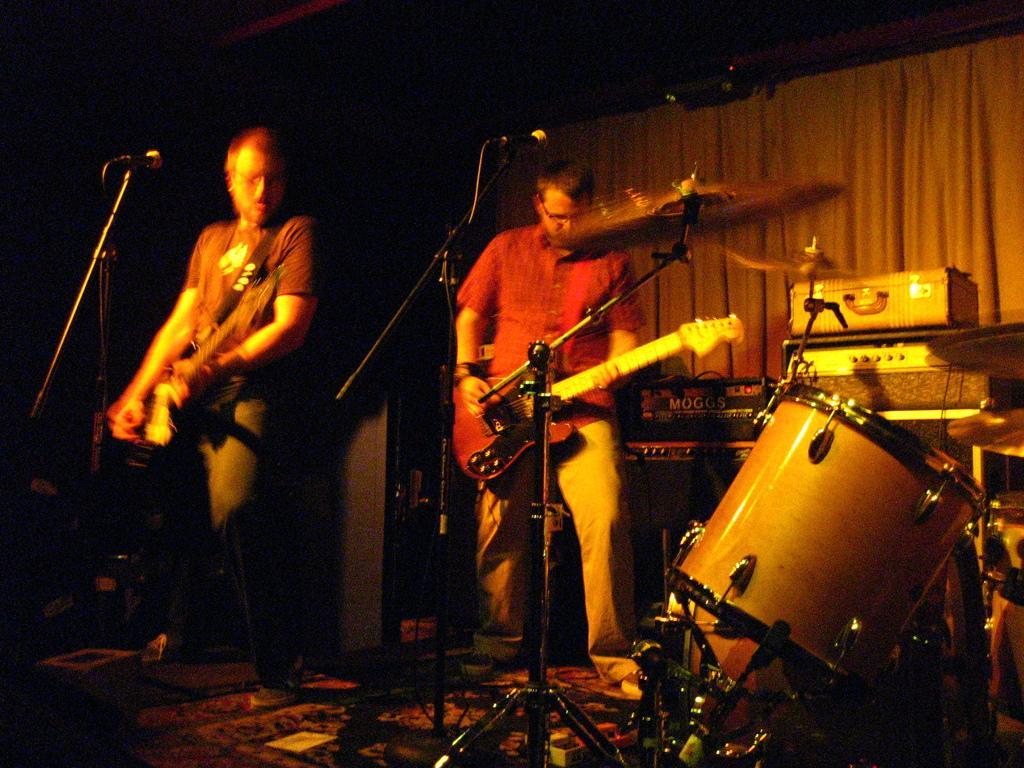Could you give a brief overview of what you see in this image? In this image I see 2 men who are standing and they are with the guitars, I can also see few musical instruments. 